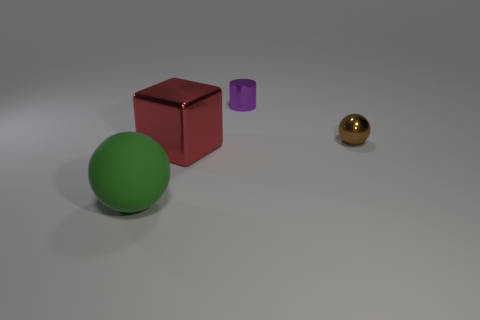Add 3 big blue rubber cubes. How many objects exist? 7 Subtract all cylinders. How many objects are left? 3 Add 3 red shiny cubes. How many red shiny cubes exist? 4 Subtract 0 purple balls. How many objects are left? 4 Subtract all red metal balls. Subtract all big red metallic blocks. How many objects are left? 3 Add 4 green matte things. How many green matte things are left? 5 